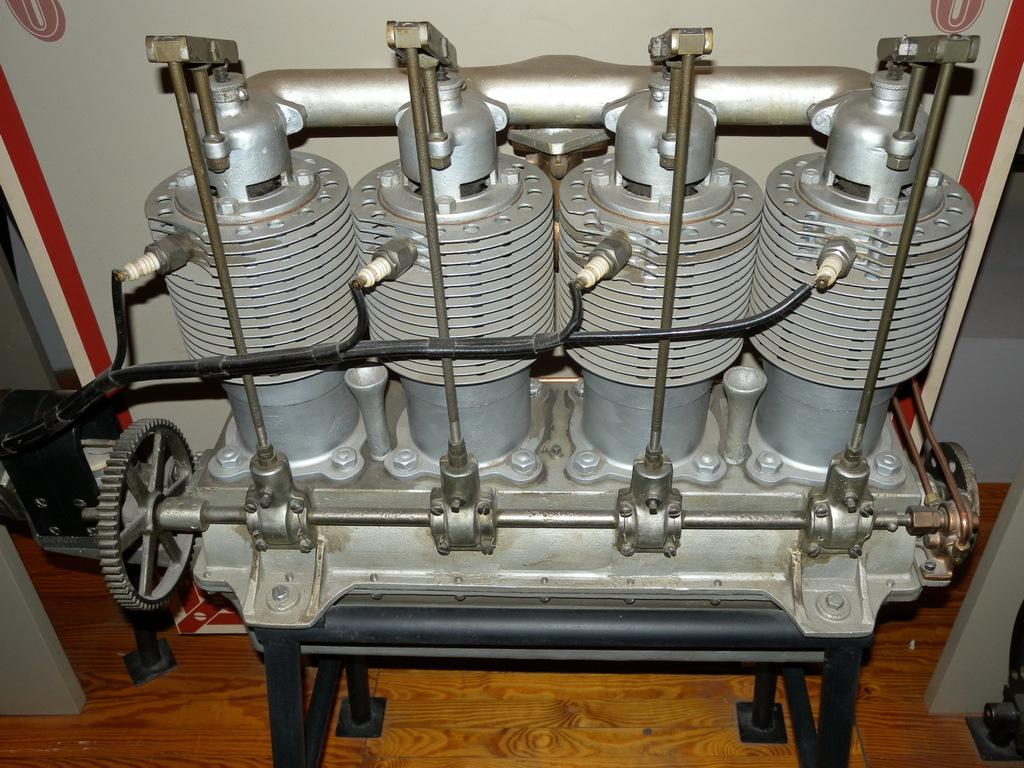What is the main subject of the image? The main subject of the image is an engine. How is the engine positioned in the image? The engine is placed on a stand. What can be seen in the background of the image? There is a white wall in the background of the image. What type of detail can be seen on the boy's shirt in the image? There is no boy present in the image. 